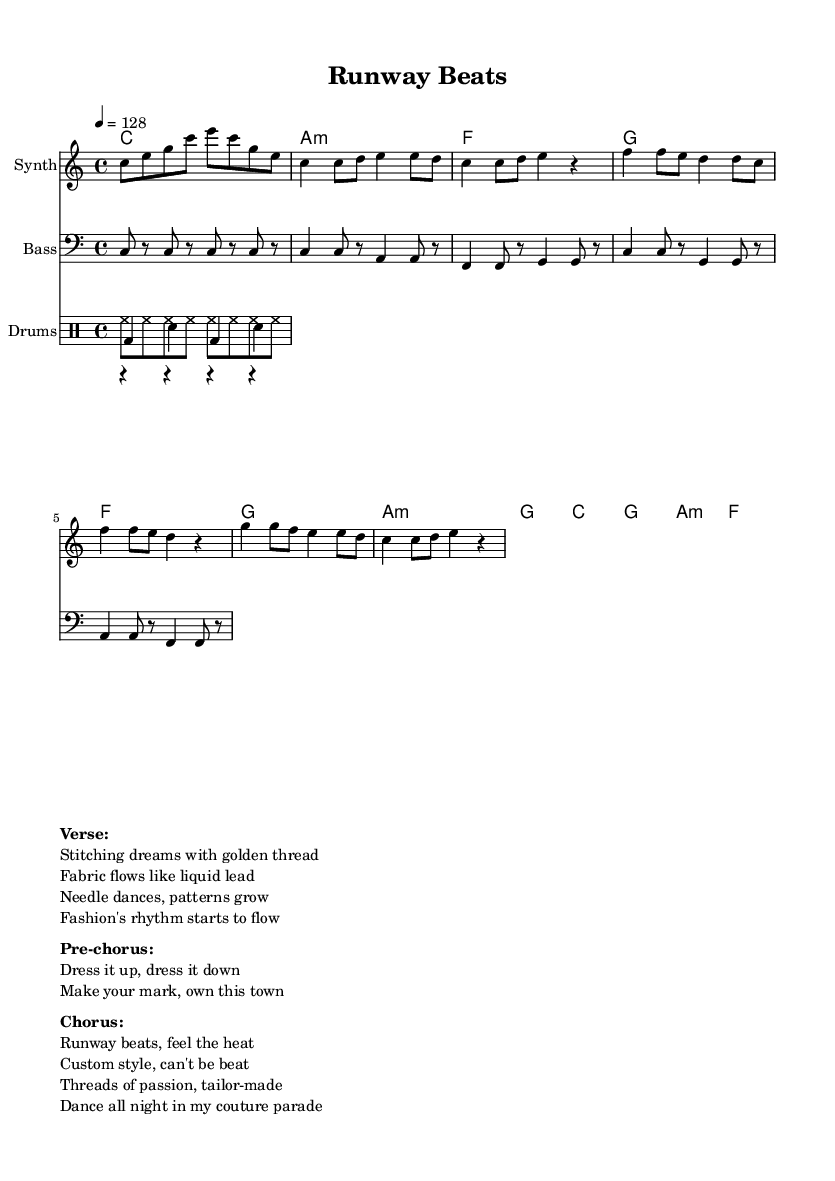What is the key signature of this music? The key signature is C major, which has no sharps or flats indicated at the beginning of the score.
Answer: C major What is the time signature of this music? The time signature is 4/4, meaning there are four beats per measure and the quarter note gets one beat. This is typically indicated at the beginning of the score.
Answer: 4/4 What is the tempo of this piece? The tempo is indicated as 128 BPM, which means there are 128 beats per minute, guiding the speed of the music.
Answer: 128 How many measures are there in the verse section? The verse section consists of 4 measures, as seen from the notation provided for that section.
Answer: 4 What instruments are featured in this arrangement? The arrangement features a Synth for the melody, Bass for the bass line, and a Drum set that includes Kick, Snare, and Hi-Hat.
Answer: Synth, Bass, Drums What lyrical theme is presented in the pre-chorus? The pre-chorus discusses themes of dressing in various styles and personal expression, emphasizing individuality and ownership of style.
Answer: Dress it up, dress it down How do the lyrics of the chorus reflect the fashion theme? The lyrics of the chorus highlight custom style and passion for fashion through phrases like "custom style" and "couture parade," connecting dance music with fashion.
Answer: Runway beats, feel the heat 